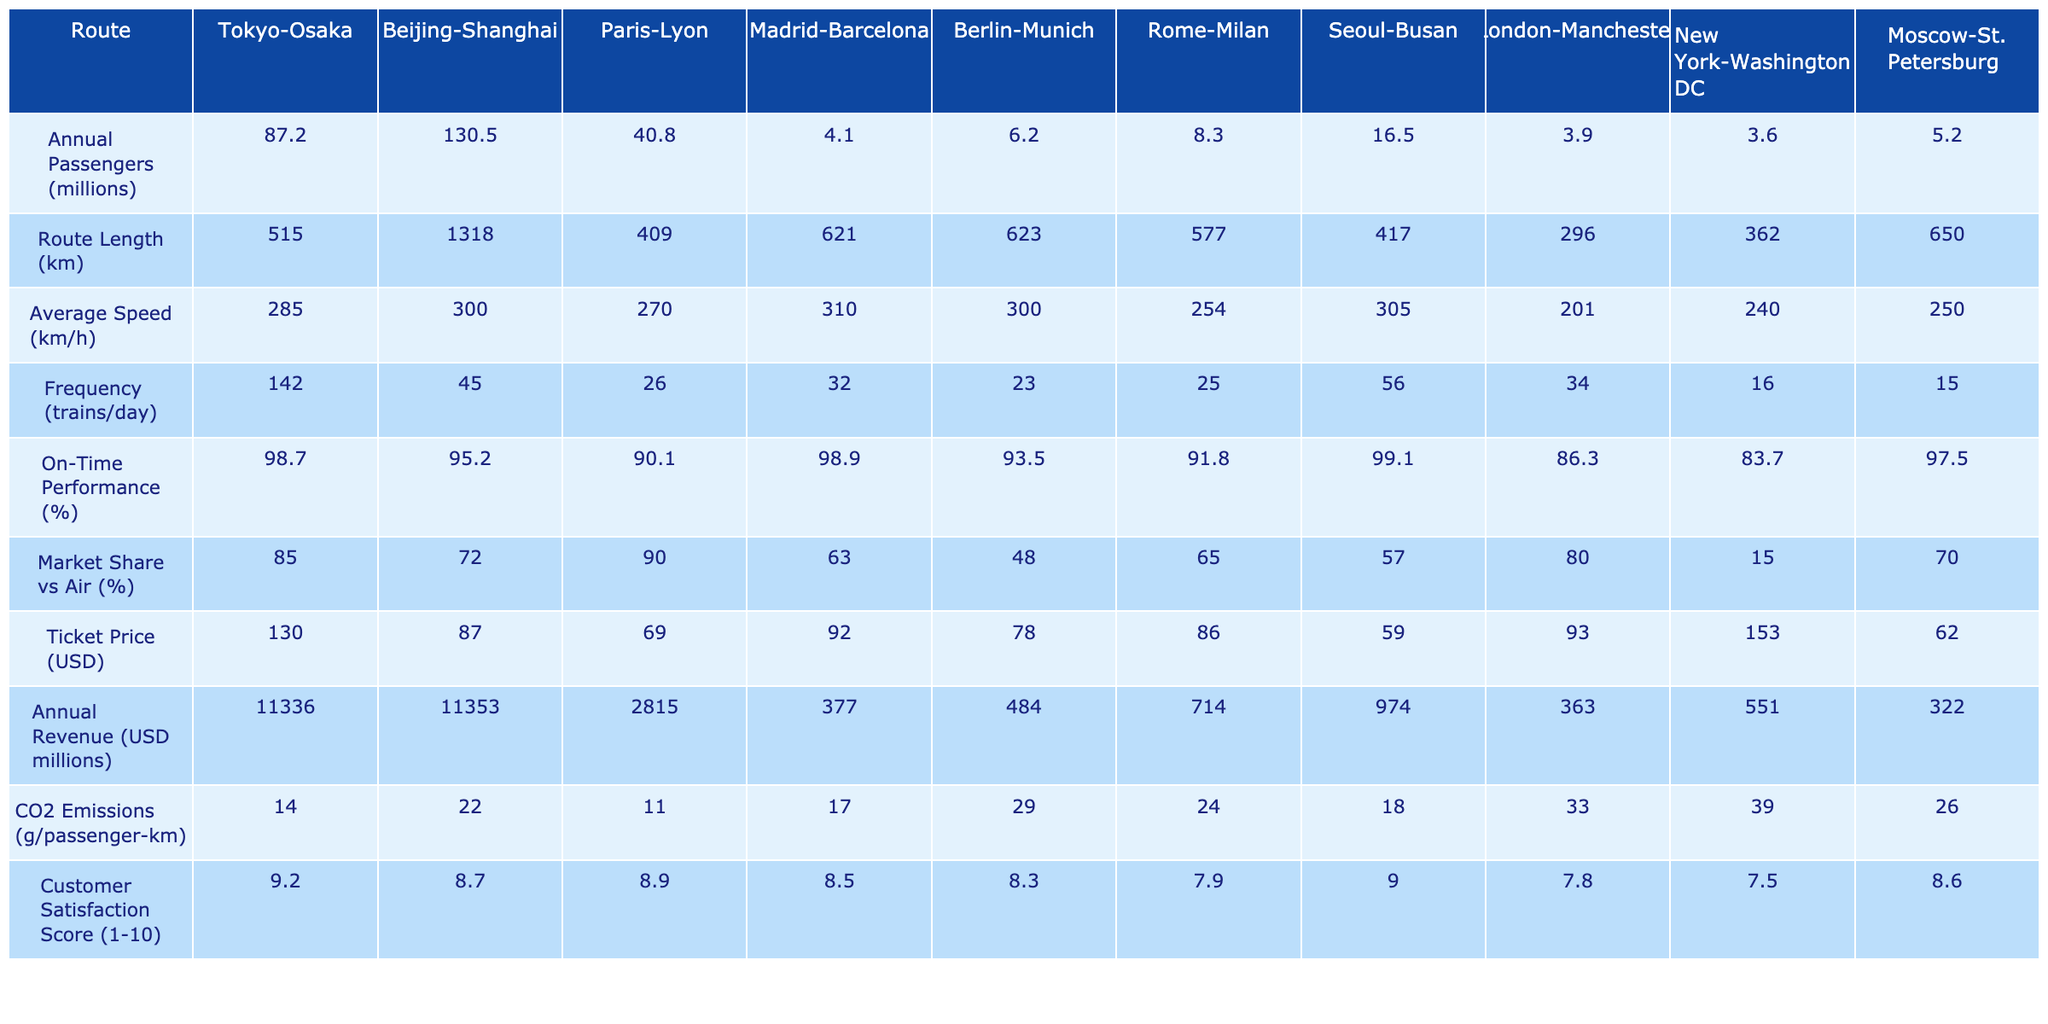What is the annual passenger volume for the Beijing-Shanghai route? The table specifies the annual passengers for each route. For the Beijing-Shanghai route, it shows 130.5 million.
Answer: 130.5 million Which route has the highest average speed? By looking at the average speed column in the table, the Beijing-Shanghai route has the highest average speed at 300 km/h.
Answer: Beijing-Shanghai What is the difference in annual passengers between the Tokyo-Osaka and Paris-Lyon routes? For Tokyo-Osaka, the annual passengers are 87.2 million, and for Paris-Lyon, it is 40.8 million. The difference is calculated as 87.2 - 40.8 = 46.4 million.
Answer: 46.4 million Which route has the highest ticket price and what is that price? The ticket prices are listed in the table. The highest ticket price is for the New York-Washington DC route at 153 USD.
Answer: 153 USD Is the on-time performance of the Madrid-Barcelona route above 95%? The on-time performance for Madrid-Barcelona is listed as 98.9%. Since 98.9% is greater than 95%, the answer is yes.
Answer: Yes What is the average annual passenger volume across all routes? To find the average, sum all the passengers: 87.2 + 130.5 + 40.8 + 4.1 + 6.2 + 8.3 + 16.5 + 3.9 + 3.6 + 5.2 = 305.3 million. Divide by the number of routes (10), which gives 305.3 / 10 = 30.53 million.
Answer: 30.53 million Which route has the lowest market share compared to air travel? The table lists the market share compared to air travel for each route. The New York-Washington DC route has the lowest market share at 15%.
Answer: New York-Washington DC What is the total CO2 emissions (in g/passenger-km) for the Berlin-Munich and Rome-Milan routes? The CO2 emissions for Berlin-Munich are 29 g/passenger-km and for Rome-Milan it is 24 g/passenger-km. Adding them gives 29 + 24 = 53 g/passenger-km.
Answer: 53 g/passenger-km What is the customer satisfaction score of the Seoul-Busan route? The customer satisfaction score for the Seoul-Busan route is 9.0 as indicated in the table.
Answer: 9.0 Is the frequency of trains per day for the London-Manchester route above 30? The frequency of trains for the London-Manchester route is 34, which is above 30. Therefore, the answer is yes.
Answer: Yes Which route has the lowest annual revenue and what is that revenue? Examining the annual revenue figures in the table, the Madrid-Barcelona route has the lowest revenue at 377 million USD.
Answer: 377 million USD 